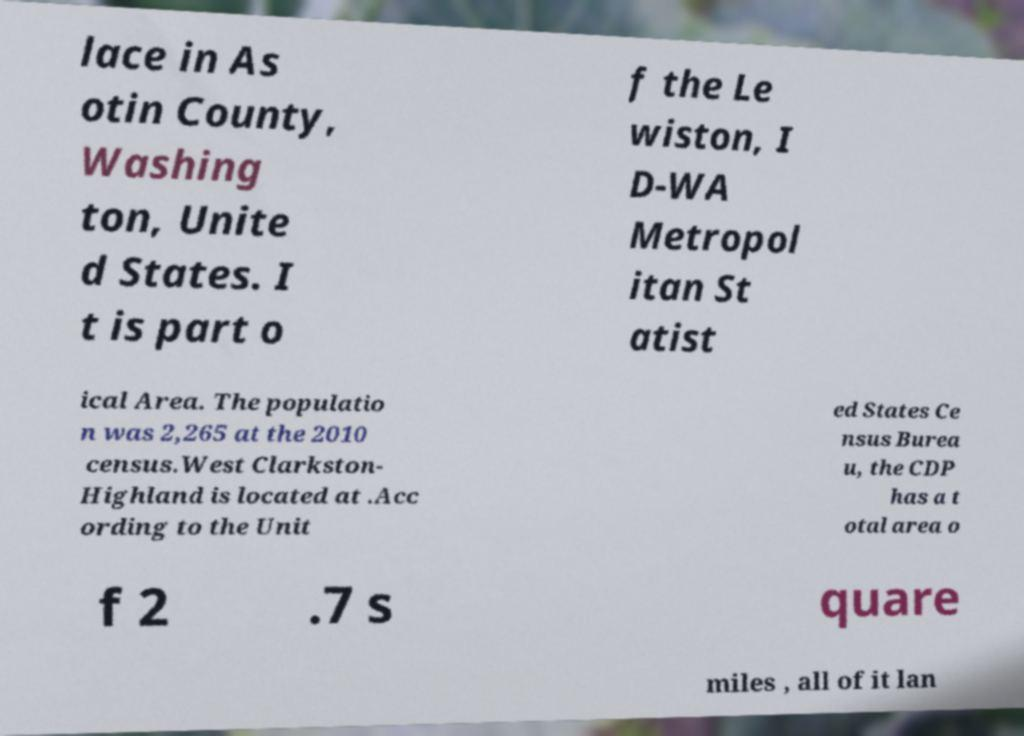Could you extract and type out the text from this image? lace in As otin County, Washing ton, Unite d States. I t is part o f the Le wiston, I D-WA Metropol itan St atist ical Area. The populatio n was 2,265 at the 2010 census.West Clarkston- Highland is located at .Acc ording to the Unit ed States Ce nsus Burea u, the CDP has a t otal area o f 2 .7 s quare miles , all of it lan 